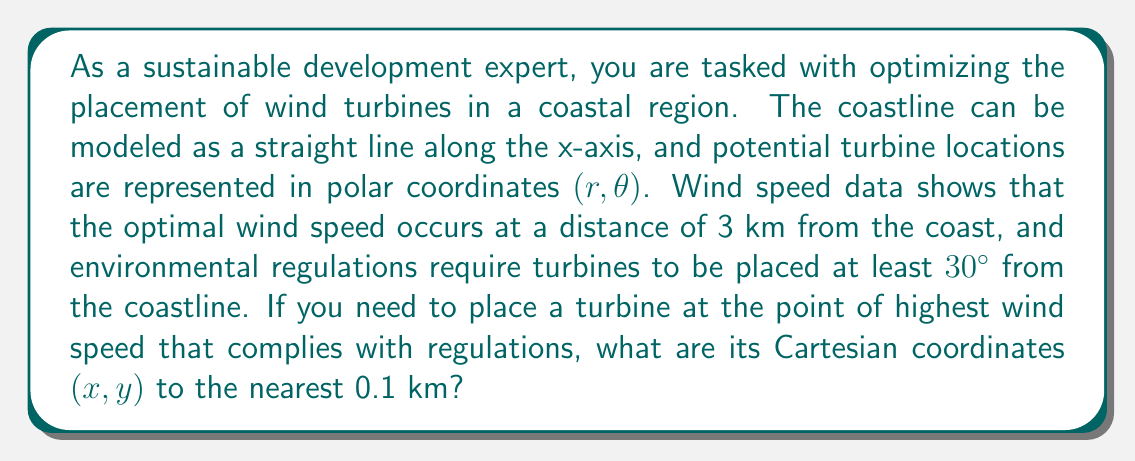Give your solution to this math problem. To solve this problem, we'll follow these steps:

1) First, we need to understand the given information:
   - The coastline is along the x-axis
   - The optimal location is 3 km from the coast $(r = 3)$
   - The angle must be at least 30° from the coastline $(\theta \geq 30°)$

2) The point we're looking for will be at $(r = 3, \theta = 30°)$ in polar coordinates.

3) To convert from polar to Cartesian coordinates, we use these formulas:
   $x = r \cos(\theta)$
   $y = r \sin(\theta)$

4) Substituting our values:
   $x = 3 \cos(30°)$
   $y = 3 \sin(30°)$

5) Calculating:
   $x = 3 \cos(30°) = 3 \cdot \frac{\sqrt{3}}{2} \approx 2.598$ km
   $y = 3 \sin(30°) = 3 \cdot \frac{1}{2} = 1.5$ km

6) Rounding to the nearest 0.1 km:
   $x \approx 2.6$ km
   $y = 1.5$ km

Therefore, the optimal location for the wind turbine in Cartesian coordinates is approximately (2.6, 1.5) km.

[asy]
import geometry;

size(200);
draw((-1,0)--(5,0), arrow=Arrow(TeXHead));
draw((0,-1)--(0,3), arrow=Arrow(TeXHead));
label("x", (5,0), E);
label("y", (0,3), N);

draw((0,0)--(2.6,1.5), arrow=Arrow(TeXHead));
draw(arc((0,0), 1, 0, 30), L="30°");

dot((2.6,1.5));
label("(2.6, 1.5)", (2.6,1.5), NE);

draw((2.6,0)--(2.6,1.5), dashed);
draw((0,0)--(2.6,0), dashed);
[/asy]
Answer: (2.6, 1.5) km 